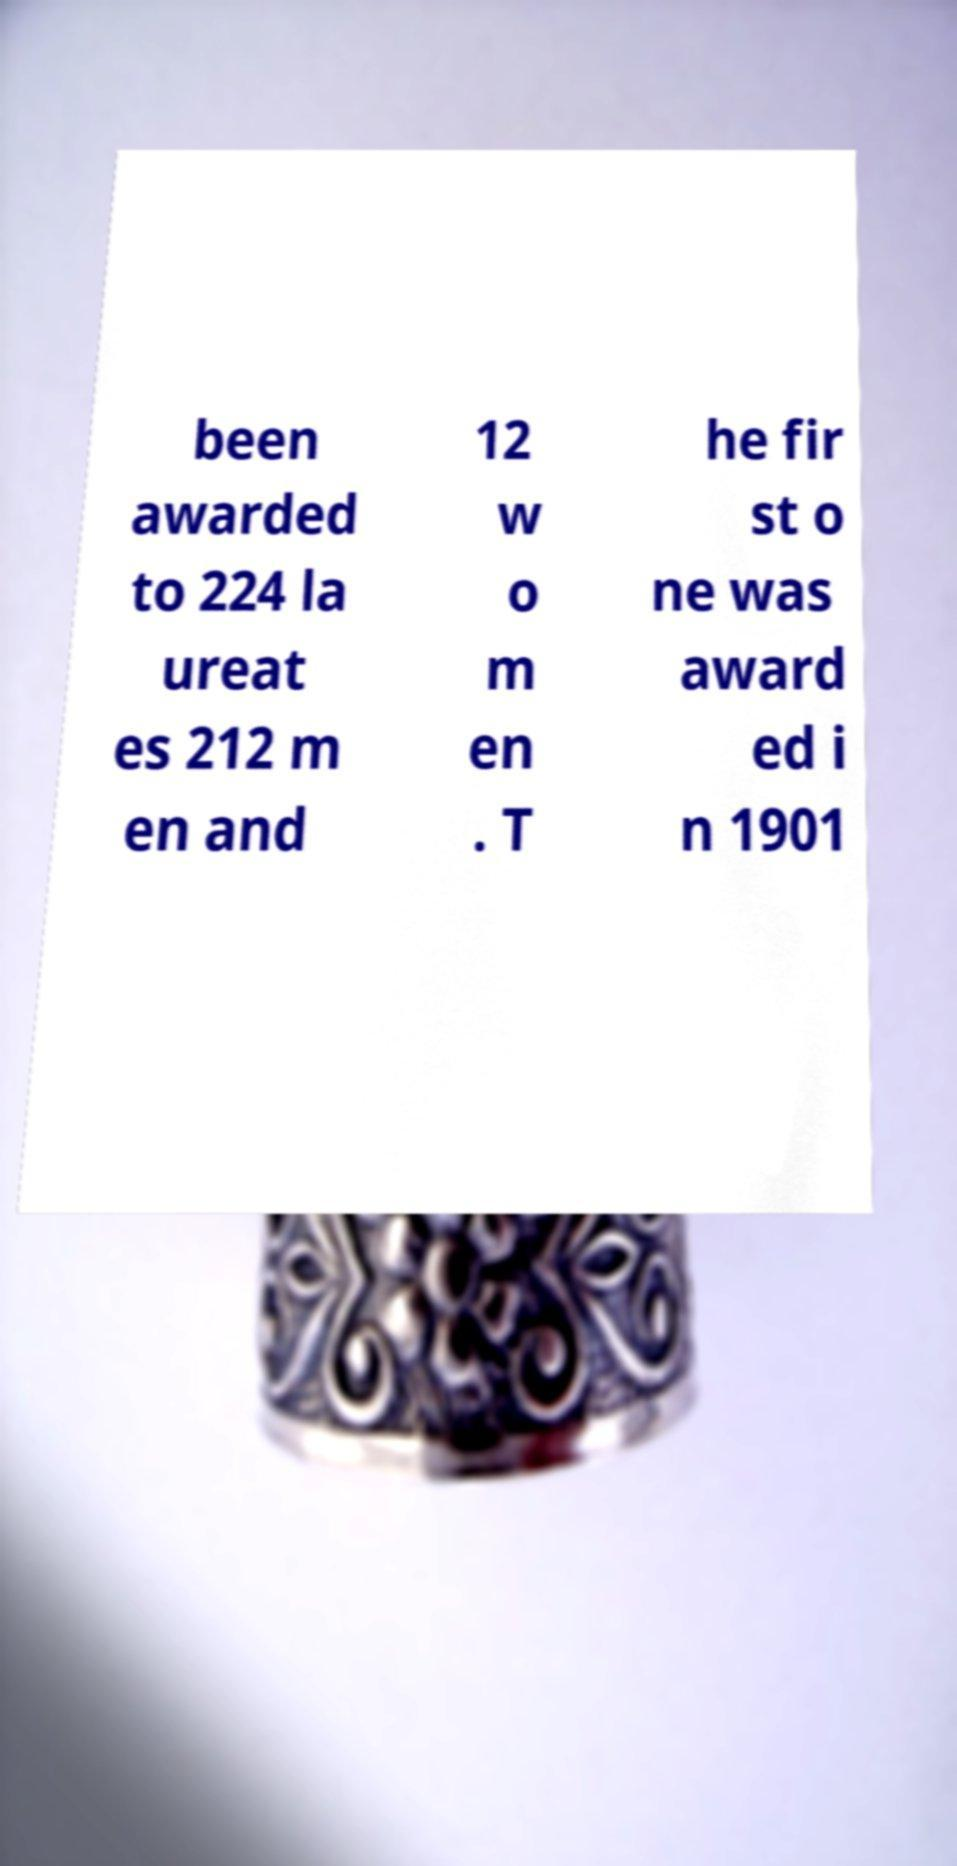Please read and relay the text visible in this image. What does it say? been awarded to 224 la ureat es 212 m en and 12 w o m en . T he fir st o ne was award ed i n 1901 